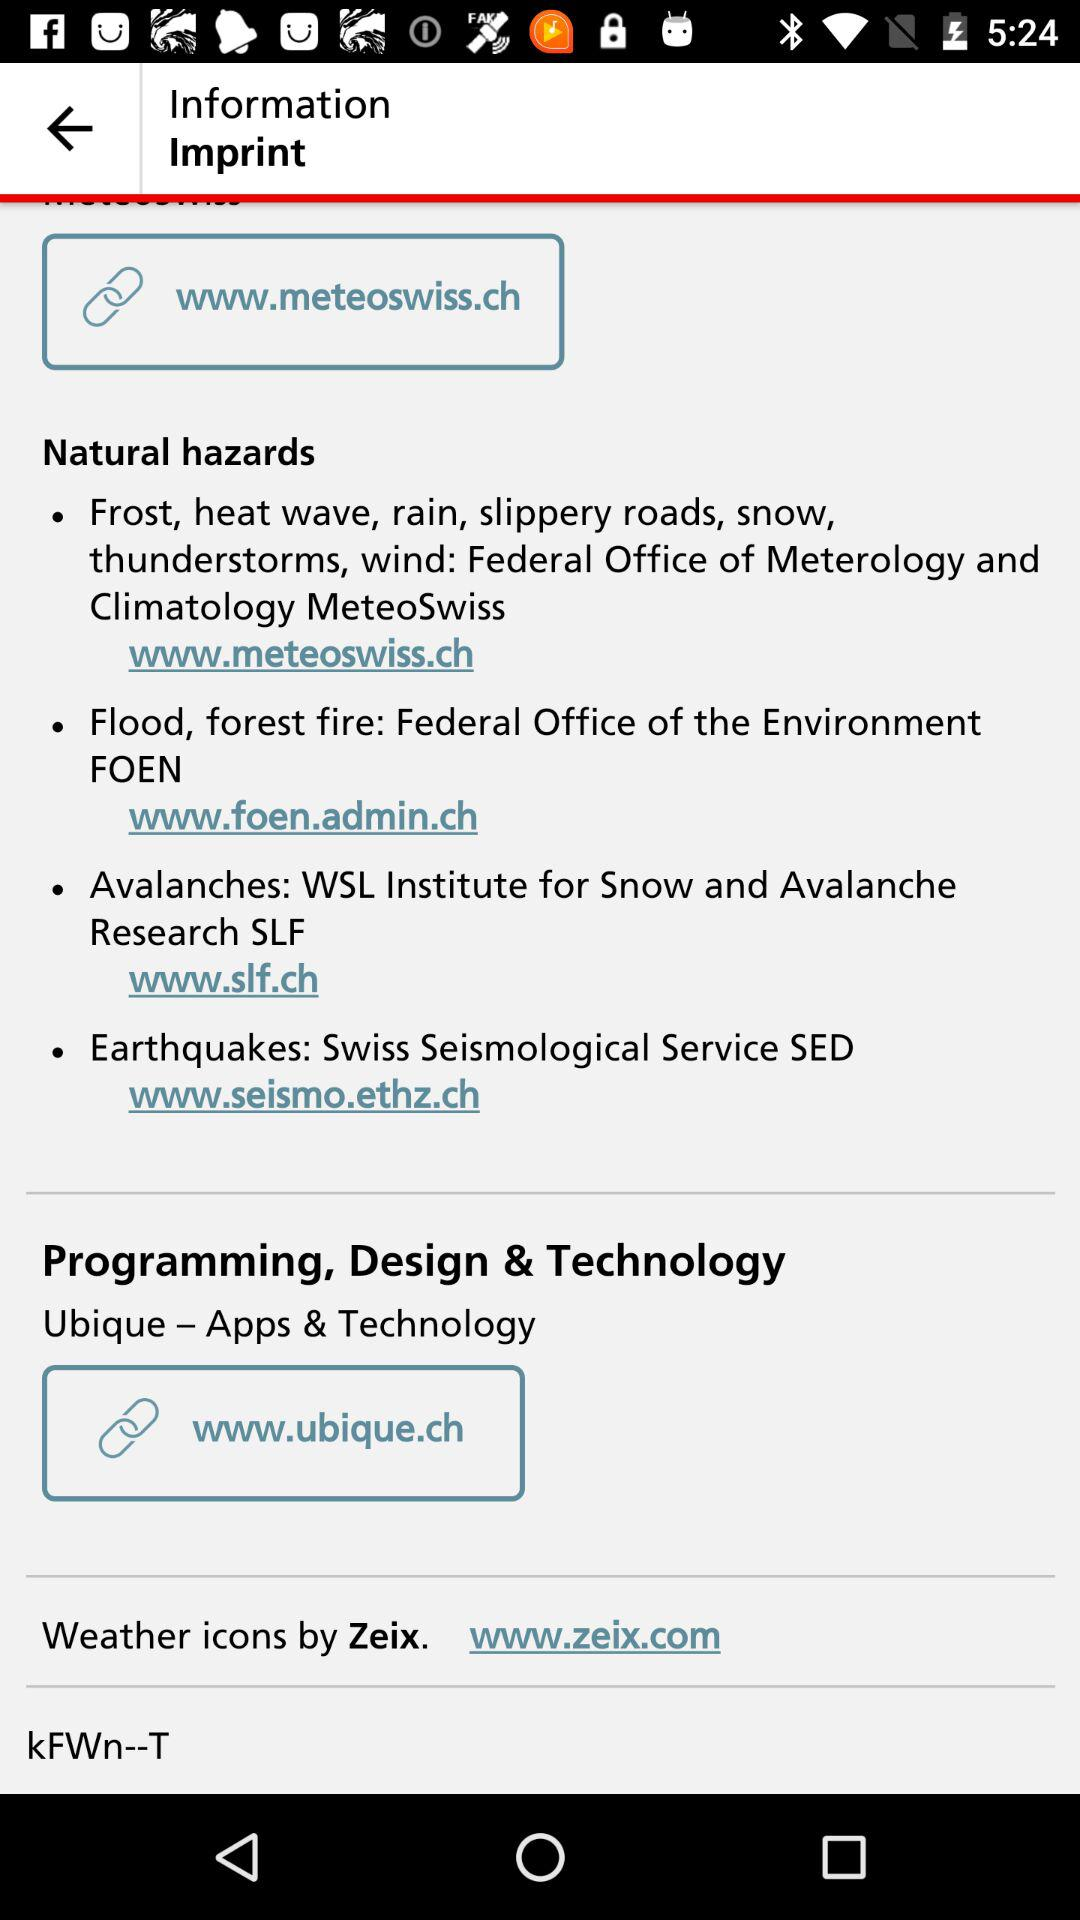How many organizations handle natural hazards?
Answer the question using a single word or phrase. 4 